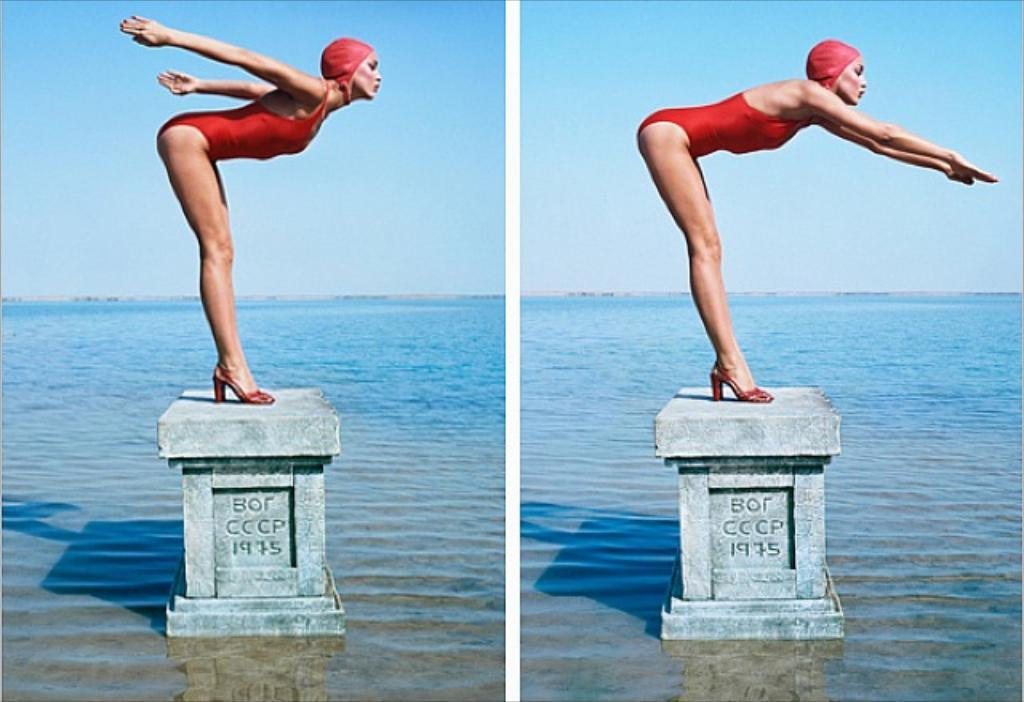What is the woman doing in the image? The woman is standing on a pillar in the image. What can be seen on the pillar besides the woman? There is text written on the pillar. What is visible in the background of the image? Water is visible in the image. How many cherries are floating in the water in the image? There are no cherries present in the image; only the woman standing on the pillar and the text on the pillar are visible. 